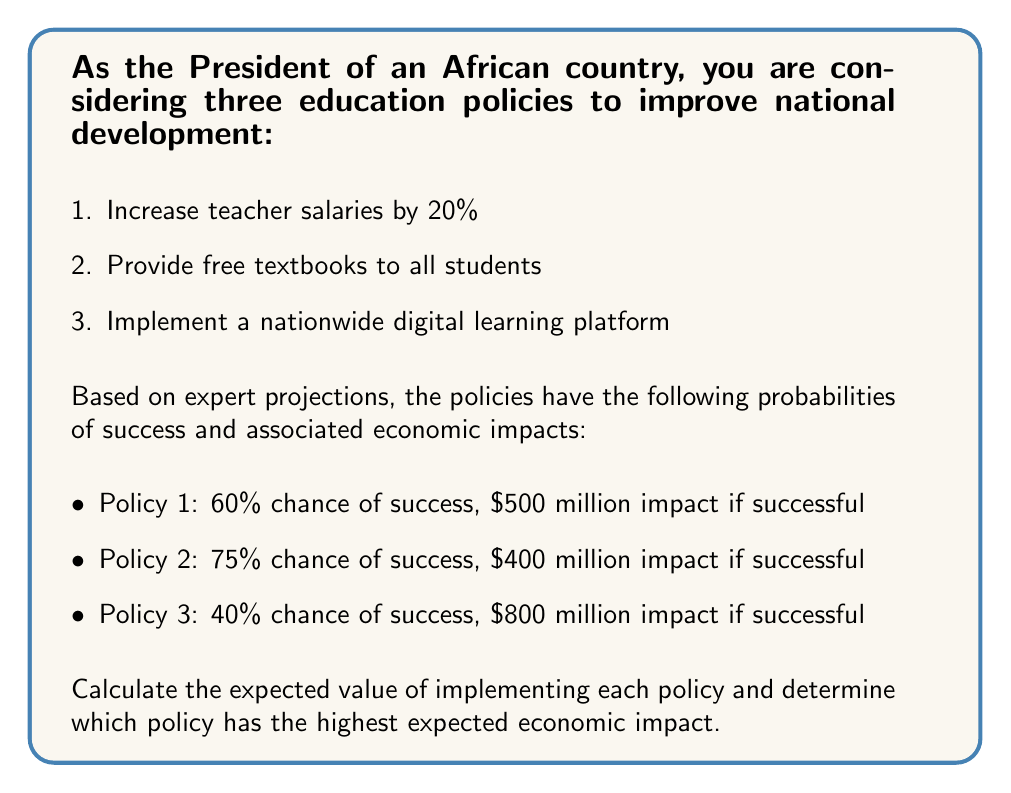Teach me how to tackle this problem. To solve this problem, we need to calculate the expected value for each policy using the formula:

$$ E(X) = p(X) \cdot v(X) $$

Where $E(X)$ is the expected value, $p(X)$ is the probability of success, and $v(X)$ is the value (economic impact) if successful.

For Policy 1:
$$ E(X_1) = 0.60 \cdot \$500\text{ million} = \$300\text{ million} $$

For Policy 2:
$$ E(X_2) = 0.75 \cdot \$400\text{ million} = \$300\text{ million} $$

For Policy 3:
$$ E(X_3) = 0.40 \cdot \$800\text{ million} = \$320\text{ million} $$

Comparing the expected values:
$$ E(X_3) > E(X_1) = E(X_2) $$

Therefore, Policy 3 (implementing a nationwide digital learning platform) has the highest expected economic impact of $320 million.
Answer: Policy 3: $320 million 